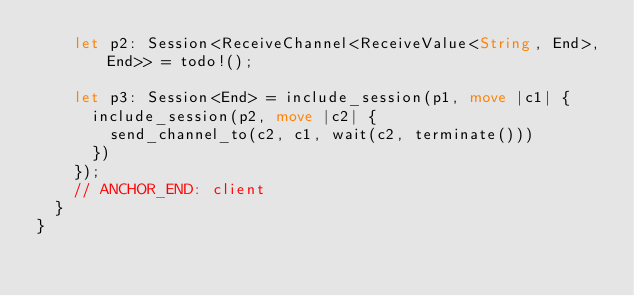Convert code to text. <code><loc_0><loc_0><loc_500><loc_500><_Rust_>    let p2: Session<ReceiveChannel<ReceiveValue<String, End>, End>> = todo!();

    let p3: Session<End> = include_session(p1, move |c1| {
      include_session(p2, move |c2| {
        send_channel_to(c2, c1, wait(c2, terminate()))
      })
    });
    // ANCHOR_END: client
  }
}
</code> 